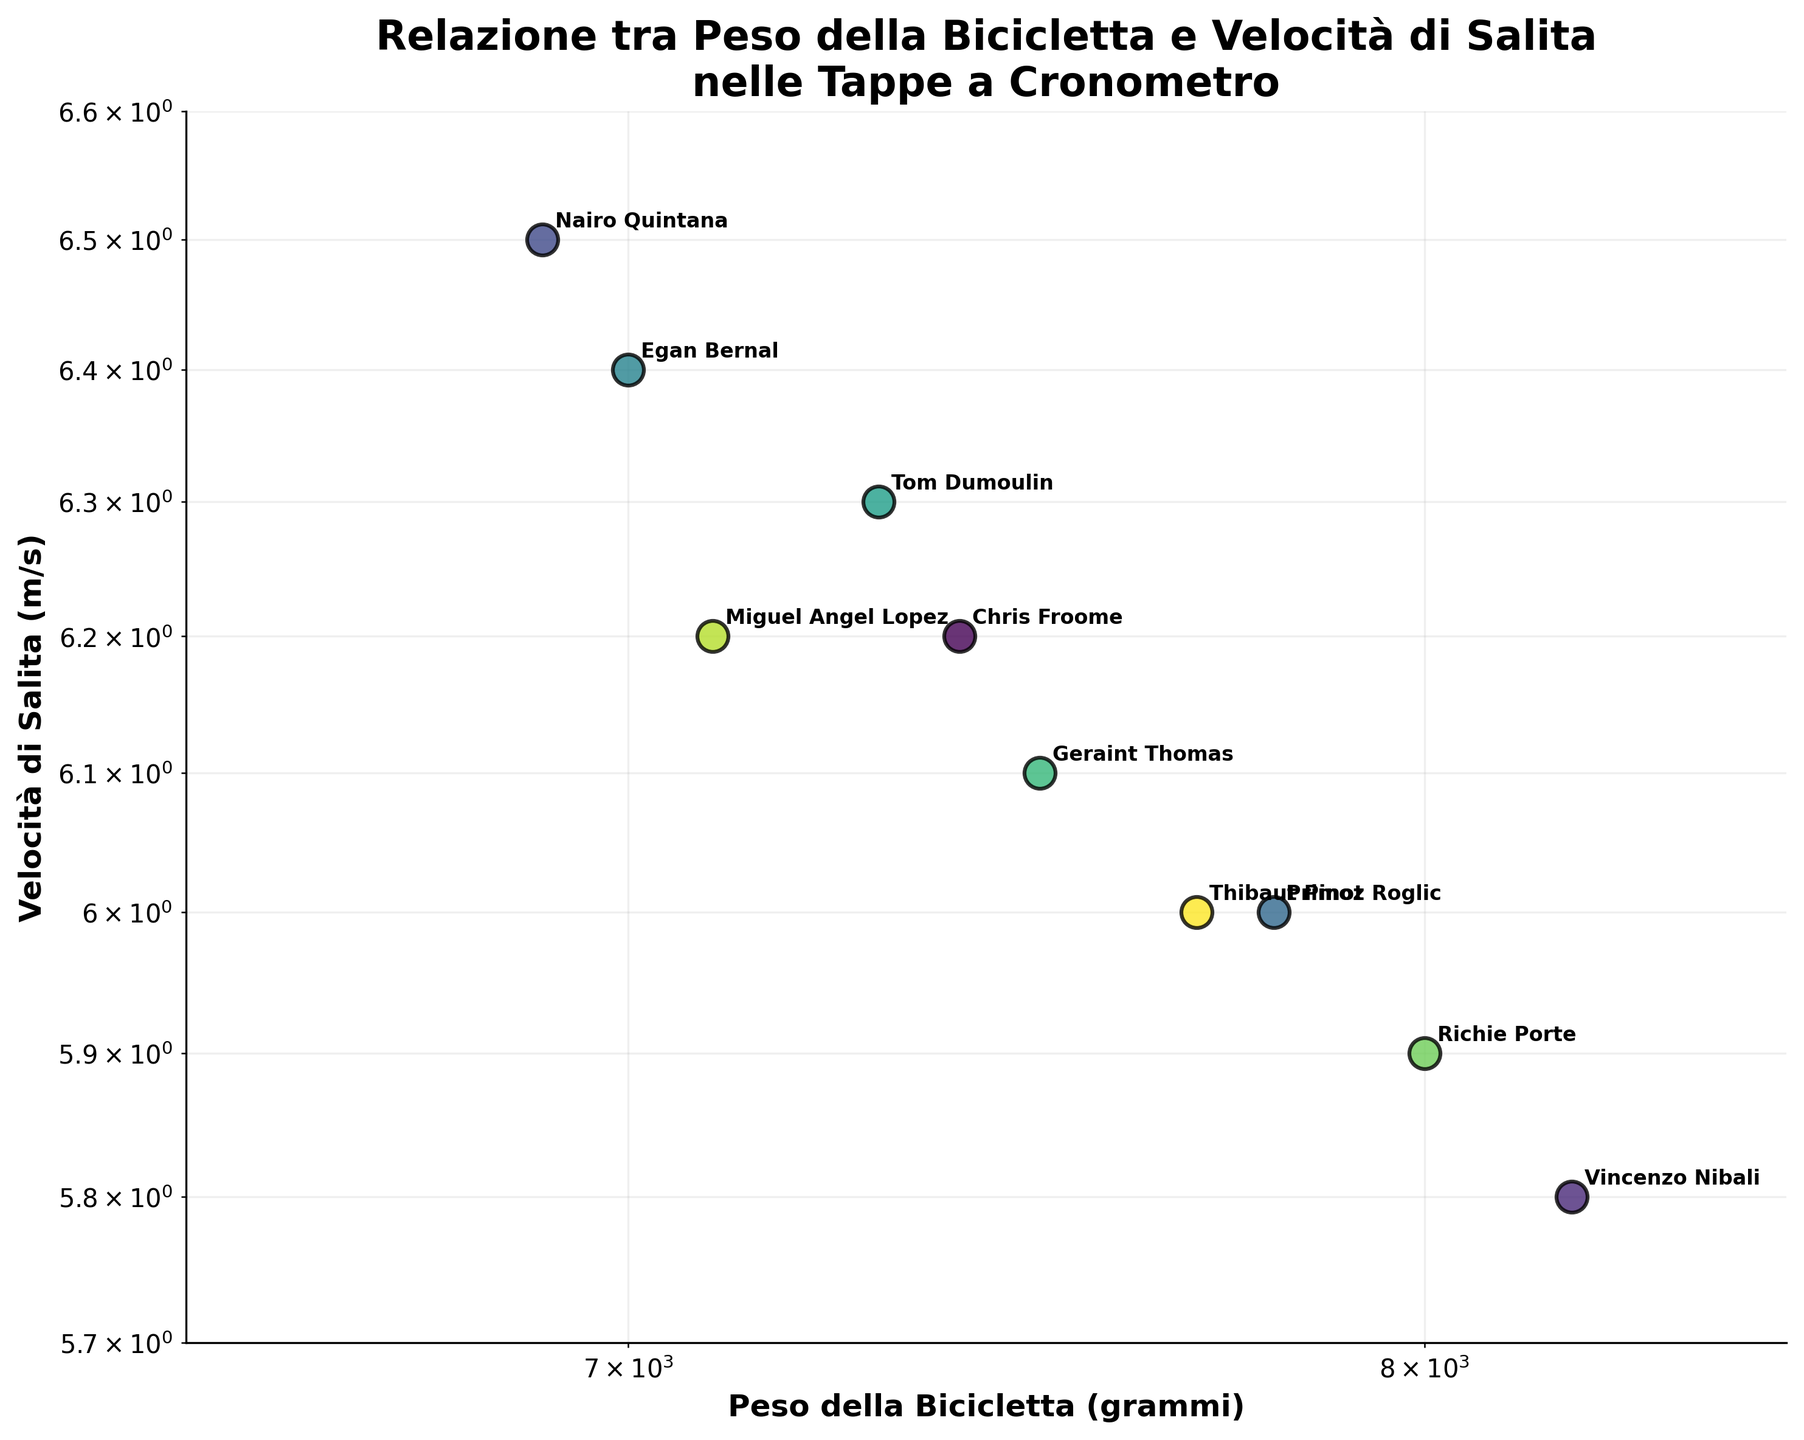What's the title of the figure? The title is prominently displayed at the top of the figure and provides an overview of what the scatter plot is depicting.
Answer: Relazione tra Peso della Bicicletta e Velocità di Salita nelle Tappe a Cronometro How many data points are plotted in the figure? Count the number of distinct cyclist names or data points marked on the scatter plot.
Answer: 10 Which cyclist has the fastest climb speed? Identify the cyclist associated with the highest value on the y-axis, which represents climb speed in m/s.
Answer: Nairo Quintana What is the bike weight of Chris Froome in grams? Find the data point labeled 'Chris Froome' and read the corresponding value on the x-axis, which represents bike weight in grams.
Answer: 7400 grams Who has a bike weight of 8000 grams? Locate the data point on the x-axis corresponding to 8000 grams and read the associated cyclist's name.
Answer: Richie Porte Is there a general trend between bike weight and climb speed? By observing the scatter plot, infer whether lower bike weights tend to correspond to higher climb speeds or vice versa.
Answer: Generally, lower bike weights correspond to higher climb speeds Which cyclist's data point is closest to the average bike weight? Calculate the average bike weight and find the cyclist whose bike weight is closest to this average value.
Answer: Tom Dumoulin (closest to 7400 grams) Compare the climb speeds of Nairo Quintana and Primoz Roglic. Who is faster? Identify the data points for Nairo Quintana and Primoz Roglic and compare their y-axis values.
Answer: Nairo Quintana Calculate the range of bike weights in the figure. Subtract the minimum bike weight from the maximum bike weight.
Answer: Range is 8200 - 6900 = 1300 grams Between Egan Bernal and Tom Dumoulin, whose bike is lighter and by how much? Identify the bike weights of Egan Bernal and Tom Dumoulin from the x-axis and calculate the difference.
Answer: Egan Bernal's bike is lighter by 300 grams 